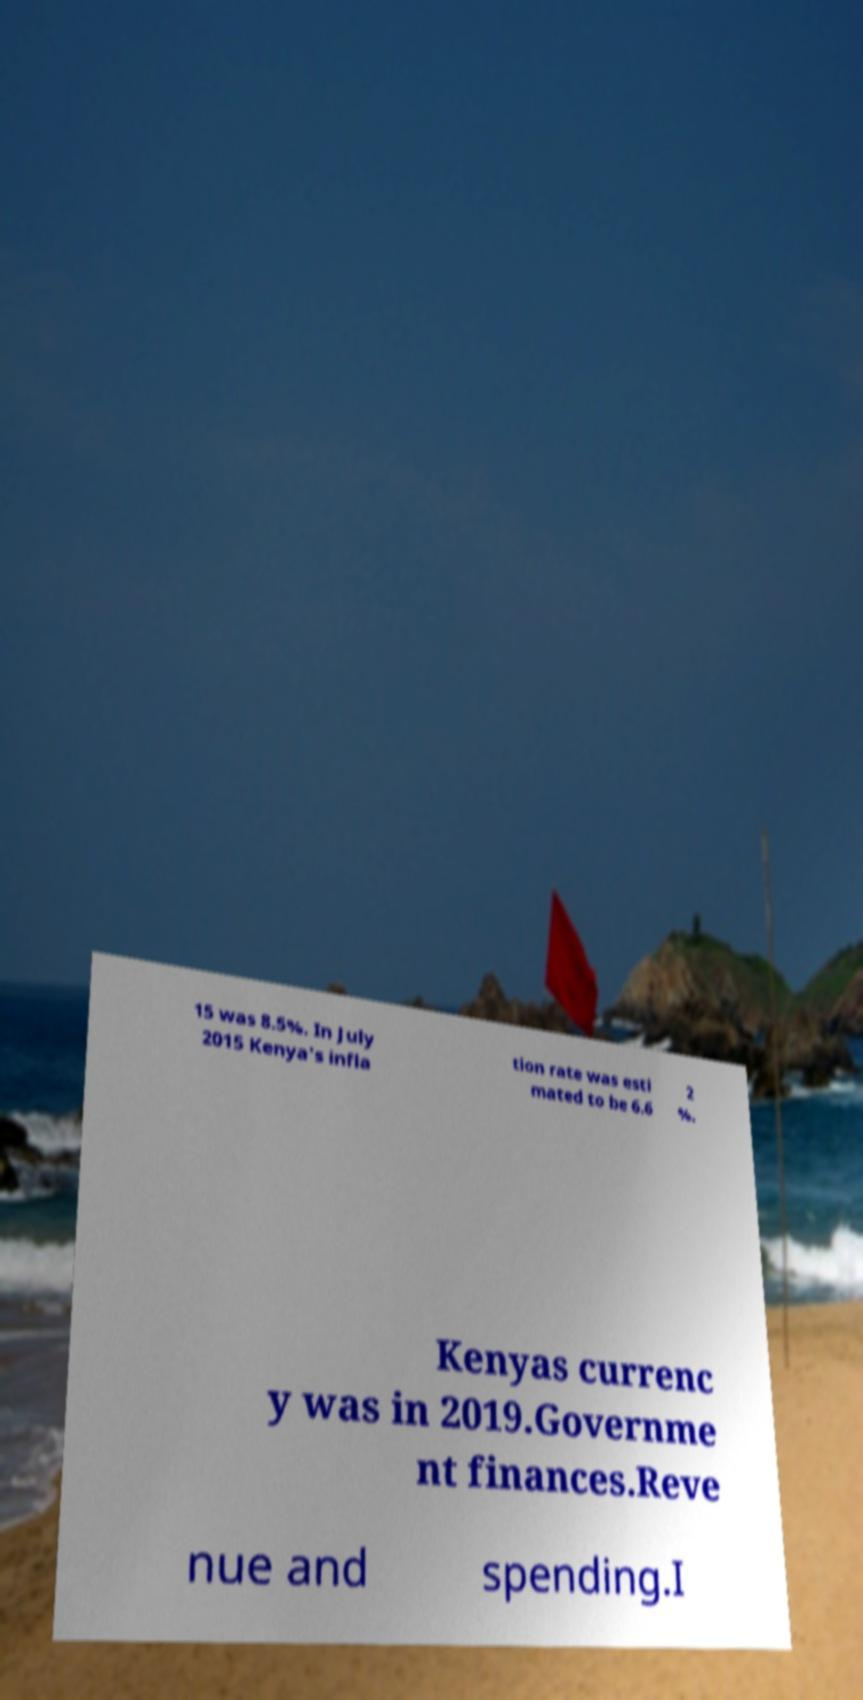Can you read and provide the text displayed in the image?This photo seems to have some interesting text. Can you extract and type it out for me? 15 was 8.5%. In July 2015 Kenya's infla tion rate was esti mated to be 6.6 2 %. Kenyas currenc y was in 2019.Governme nt finances.Reve nue and spending.I 